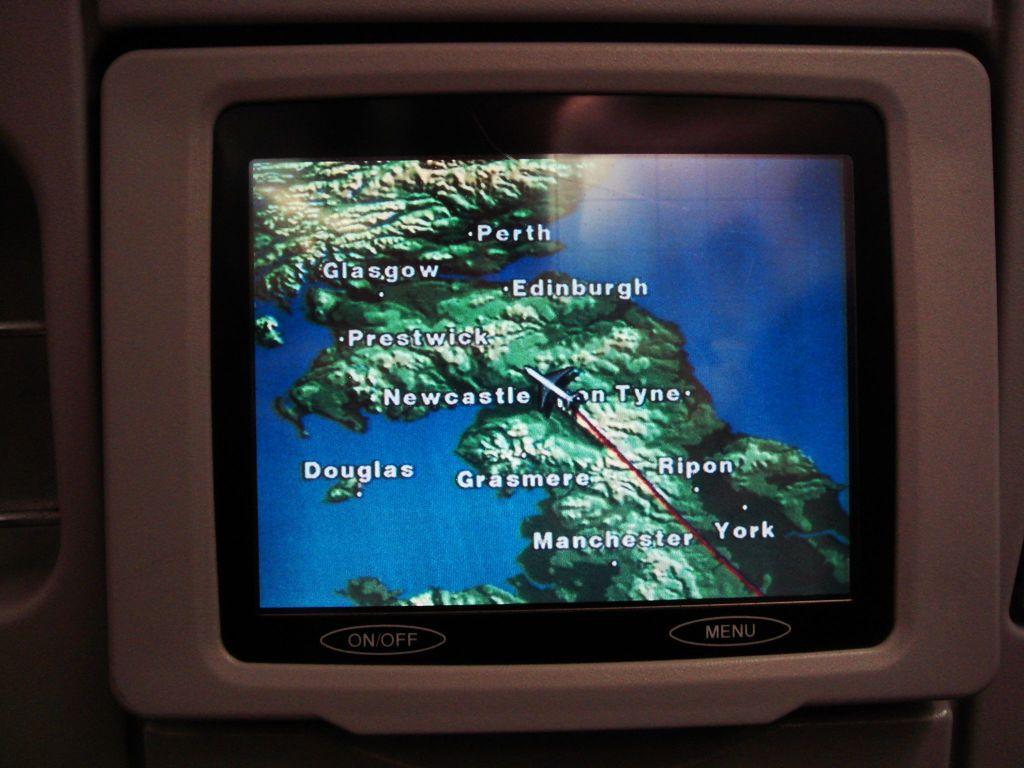<image>
Describe the image concisely. A screen displays a map showing several cities including Glasgow, Perth, and Edinburgh. 